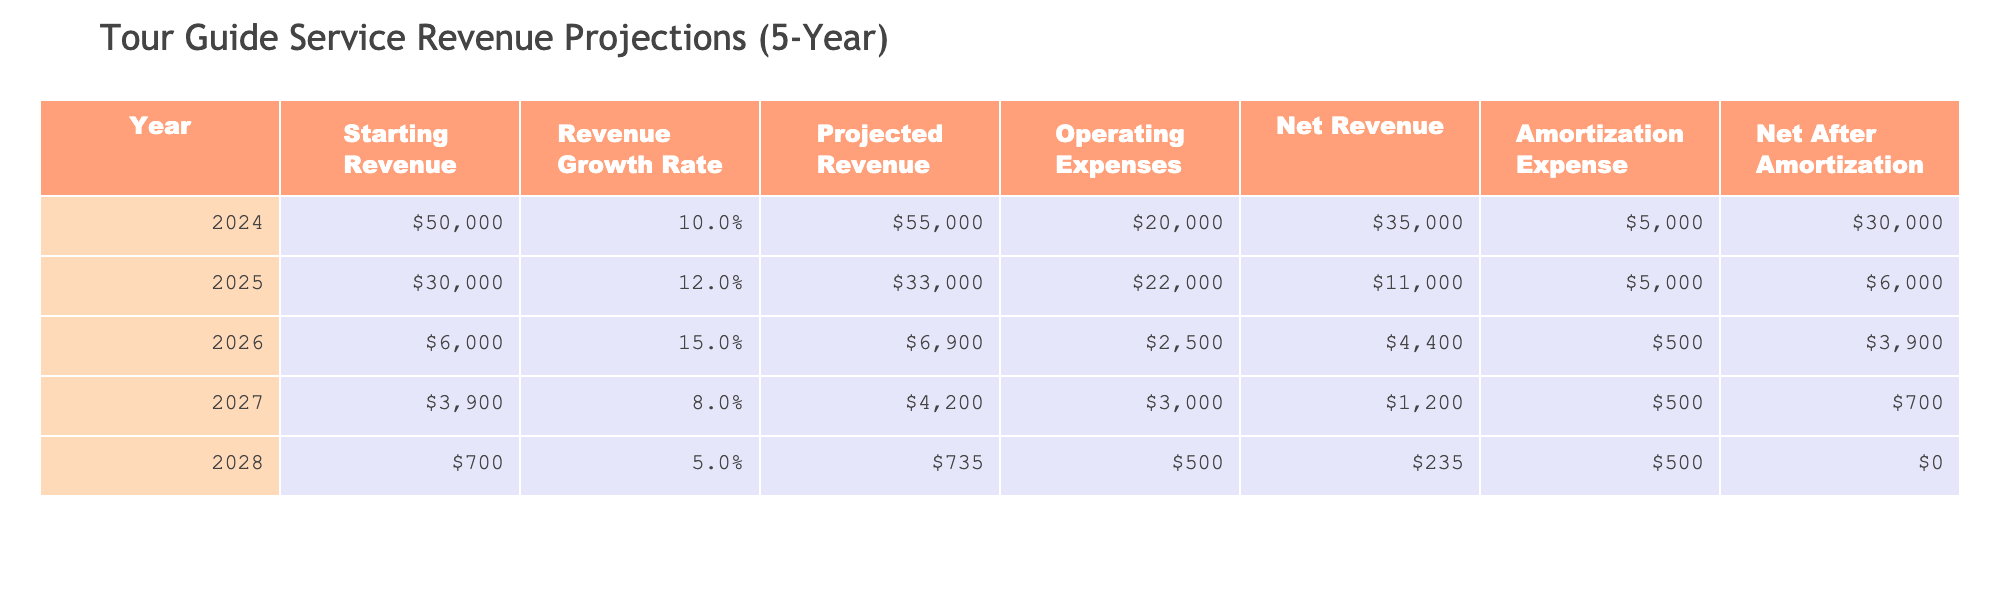What was the projected revenue for the year 2025? In the table, I can find the row for the year 2025, where the "Projected Revenue" column is listed as $33,000.
Answer: $33,000 What are the operating expenses for the year 2024? Referring to the year 2024 in the table, the "Operating Expenses" column shows the value of $20,000.
Answer: $20,000 In which year was the net revenue the highest, and what was that amount? Looking through each year's "Net Revenue" column, the highest value is $35,000 in the year 2024.
Answer: Year 2024, $35,000 What is the total net revenue over the 5 years? To calculate the total net revenue, I sum the values from the "Net Revenue" column: ($35,000 + $11,000 + $4,400 + $1,200 + $0) = $51,600.
Answer: $51,600 Was the net after amortization in 2028 greater than in 2027? In the table, the "Net After Amortization" for 2027 is $700, and for 2028 it is $0. Since $700 is greater than $0, the statement is true.
Answer: Yes What is the average projected revenue across all years? I will sum the values in the "Projected Revenue" column: ($55,000 + $33,000 + $6,900 + $4,200 + $735) = $99,835. Then, to find the average, I divide by 5 years, so $99,835 / 5 = $19,967.
Answer: $19,967 Did the operating expenses increase every year from 2024 to 2028? By comparing the operating expenses for each year: $20,000 in 2024, $22,000 in 2025, $2,500 in 2026, $3,000 in 2027, and $500 in 2028, I can see that the operating expenses do not consistently increase. For example, they decreased in 2026 and 2028.
Answer: No What was the amortization expense in the year with the lowest net after amortization? The lowest value in the "Net After Amortization" column is $0 in the year 2028, and the corresponding "Amortization Expense" for that year is $500.
Answer: $500 